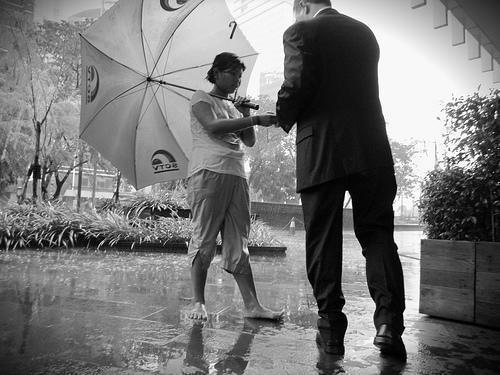How many people are there?
Give a very brief answer. 2. 